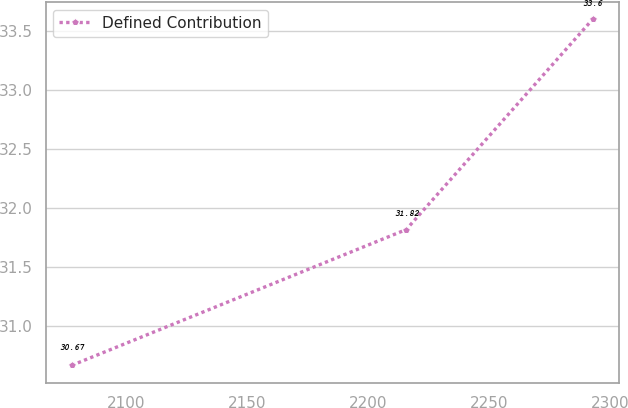Convert chart to OTSL. <chart><loc_0><loc_0><loc_500><loc_500><line_chart><ecel><fcel>Defined Contribution<nl><fcel>2077.28<fcel>30.67<nl><fcel>2215.68<fcel>31.82<nl><fcel>2292.77<fcel>33.6<nl></chart> 